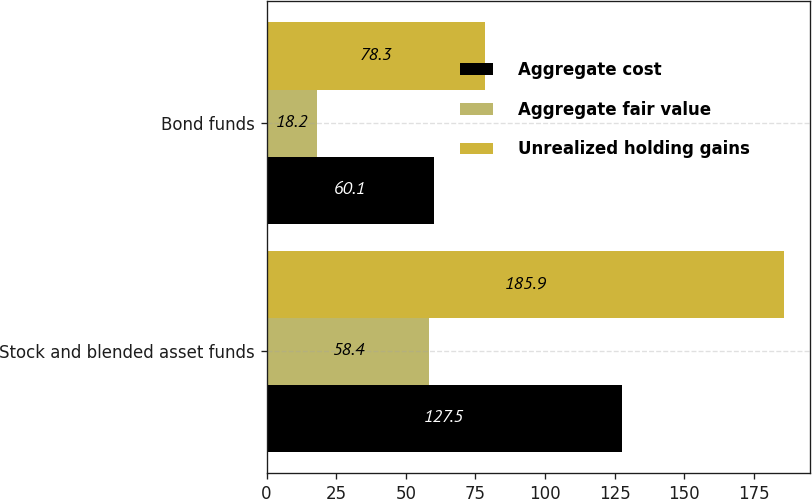Convert chart. <chart><loc_0><loc_0><loc_500><loc_500><stacked_bar_chart><ecel><fcel>Stock and blended asset funds<fcel>Bond funds<nl><fcel>Aggregate cost<fcel>127.5<fcel>60.1<nl><fcel>Aggregate fair value<fcel>58.4<fcel>18.2<nl><fcel>Unrealized holding gains<fcel>185.9<fcel>78.3<nl></chart> 